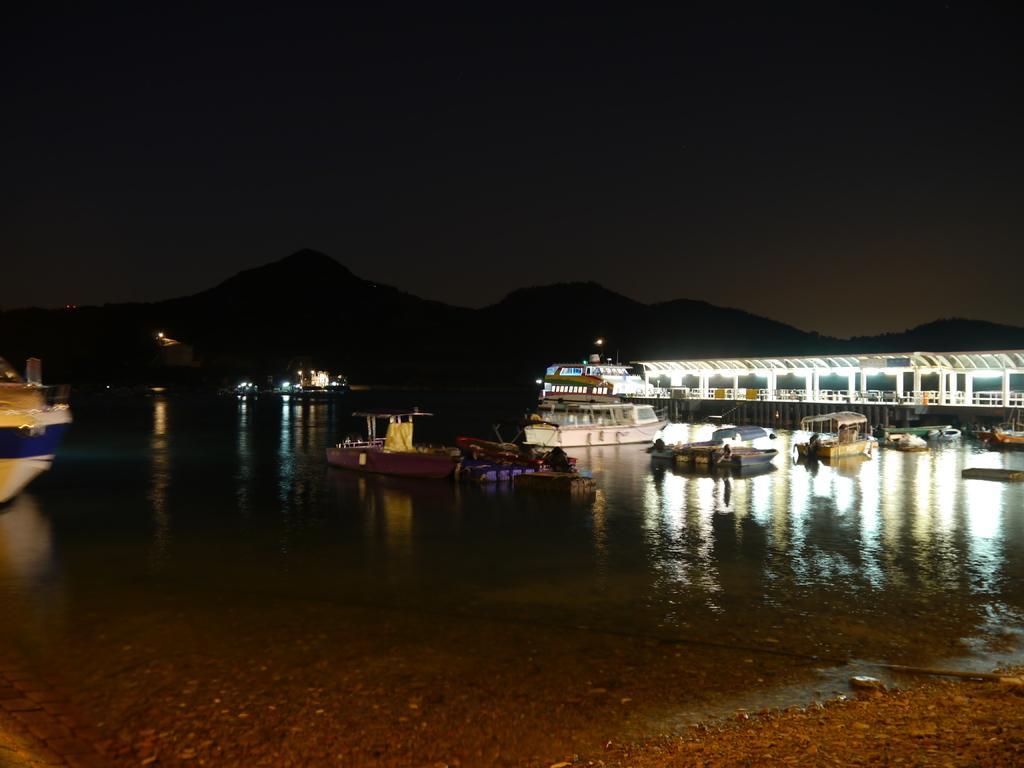How would you summarize this image in a sentence or two? In this picture we can observe water on which there are some boats floating. In the background there are hills and a sky. 